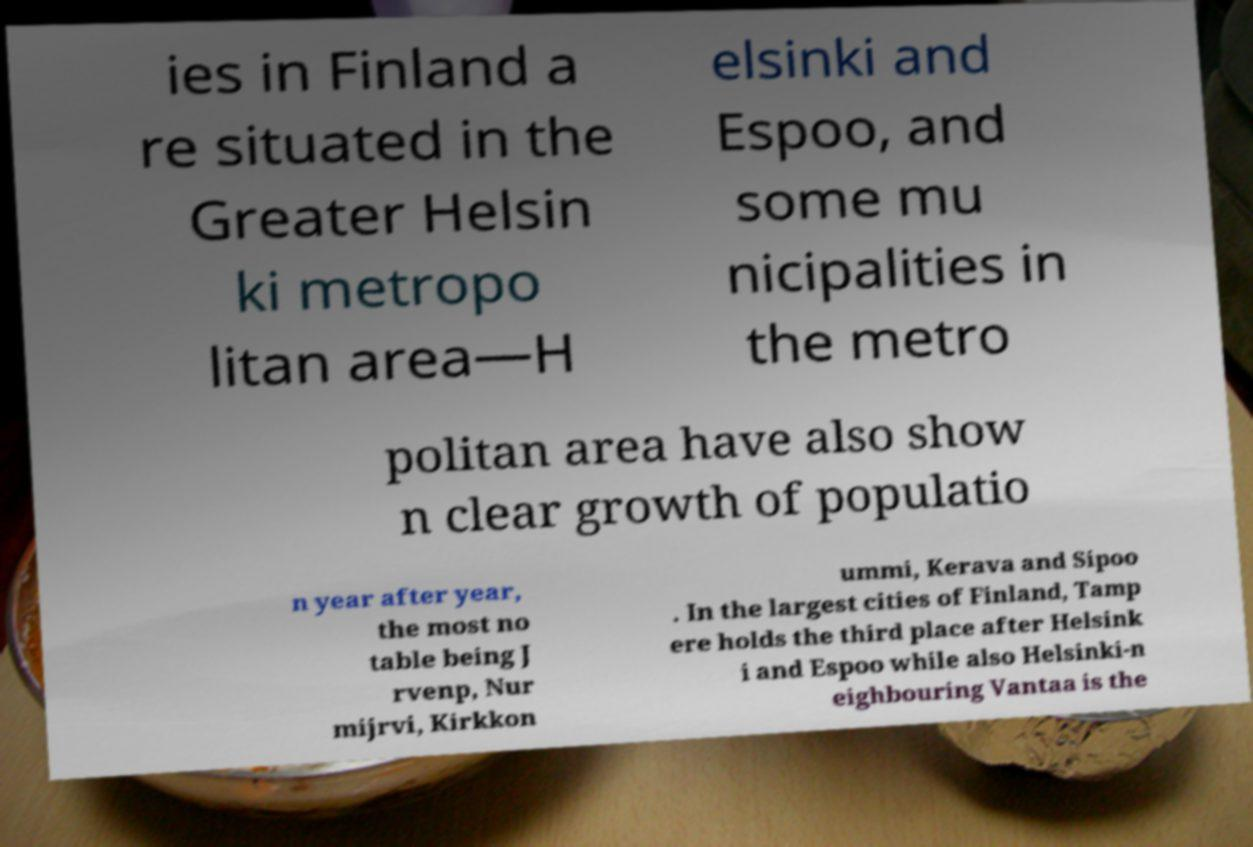Can you read and provide the text displayed in the image?This photo seems to have some interesting text. Can you extract and type it out for me? ies in Finland a re situated in the Greater Helsin ki metropo litan area—H elsinki and Espoo, and some mu nicipalities in the metro politan area have also show n clear growth of populatio n year after year, the most no table being J rvenp, Nur mijrvi, Kirkkon ummi, Kerava and Sipoo . In the largest cities of Finland, Tamp ere holds the third place after Helsink i and Espoo while also Helsinki-n eighbouring Vantaa is the 